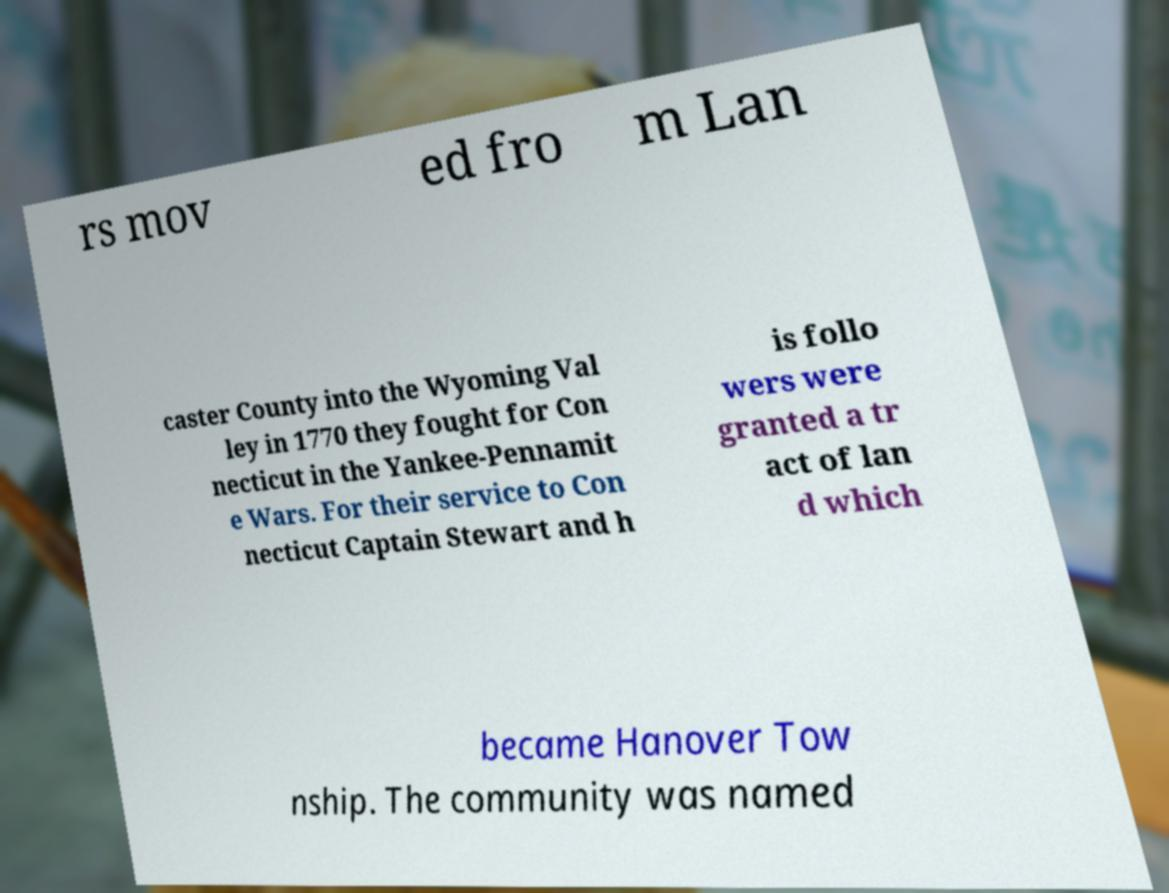Can you accurately transcribe the text from the provided image for me? rs mov ed fro m Lan caster County into the Wyoming Val ley in 1770 they fought for Con necticut in the Yankee-Pennamit e Wars. For their service to Con necticut Captain Stewart and h is follo wers were granted a tr act of lan d which became Hanover Tow nship. The community was named 